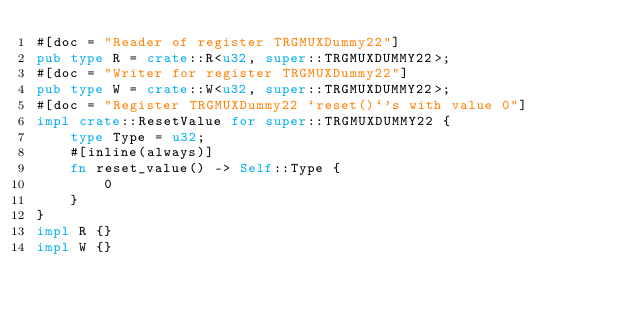Convert code to text. <code><loc_0><loc_0><loc_500><loc_500><_Rust_>#[doc = "Reader of register TRGMUXDummy22"]
pub type R = crate::R<u32, super::TRGMUXDUMMY22>;
#[doc = "Writer for register TRGMUXDummy22"]
pub type W = crate::W<u32, super::TRGMUXDUMMY22>;
#[doc = "Register TRGMUXDummy22 `reset()`'s with value 0"]
impl crate::ResetValue for super::TRGMUXDUMMY22 {
    type Type = u32;
    #[inline(always)]
    fn reset_value() -> Self::Type {
        0
    }
}
impl R {}
impl W {}
</code> 